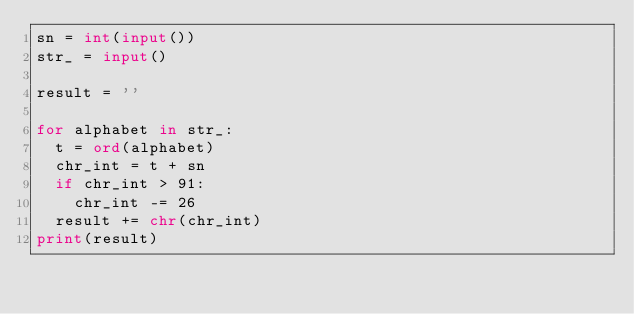<code> <loc_0><loc_0><loc_500><loc_500><_Python_>sn = int(input())
str_ = input()

result = ''

for alphabet in str_:
  t = ord(alphabet)
  chr_int = t + sn
  if chr_int > 91:
    chr_int -= 26
  result += chr(chr_int)
print(result)</code> 